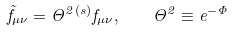Convert formula to latex. <formula><loc_0><loc_0><loc_500><loc_500>\tilde { f } _ { \mu \nu } = \Theta ^ { 2 } { ^ { ( s ) } } f _ { \mu \nu } , \quad \Theta ^ { 2 } \equiv e ^ { - \Phi }</formula> 